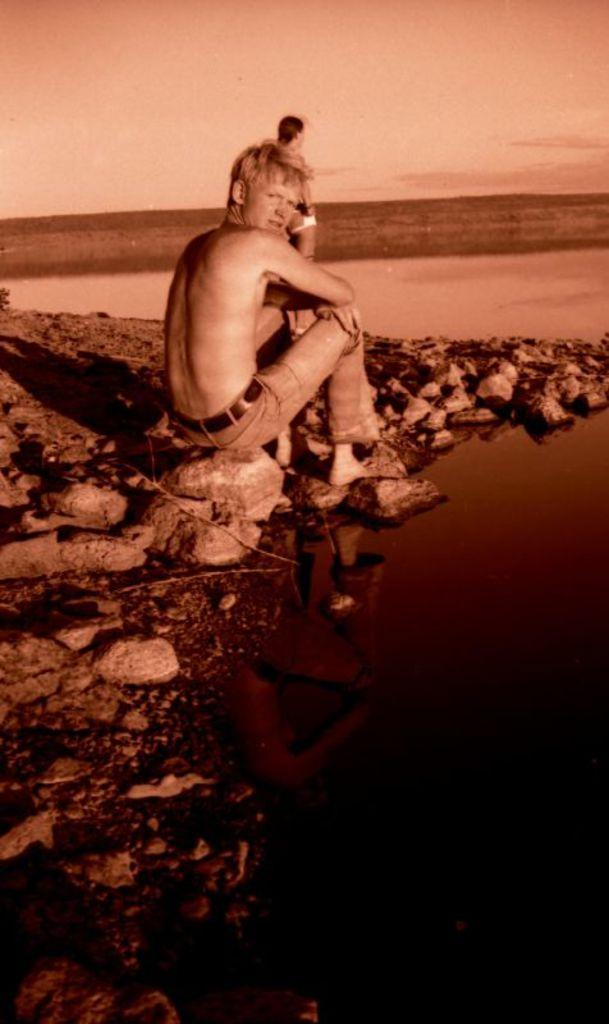What is the primary element in the image? There is water in the image. What can be seen near the water? There are rocks near the water near the water. What is the person sitting on the rocks doing? The person is sitting on the rocks. Can you describe the other person in the image? There is another person standing in the background. What is visible in the background of the image? The sky is visible in the background. What type of volleyball game is being played in the image? There is no volleyball game present in the image. What role does the minister play in the image? There is no minister present in the image. 